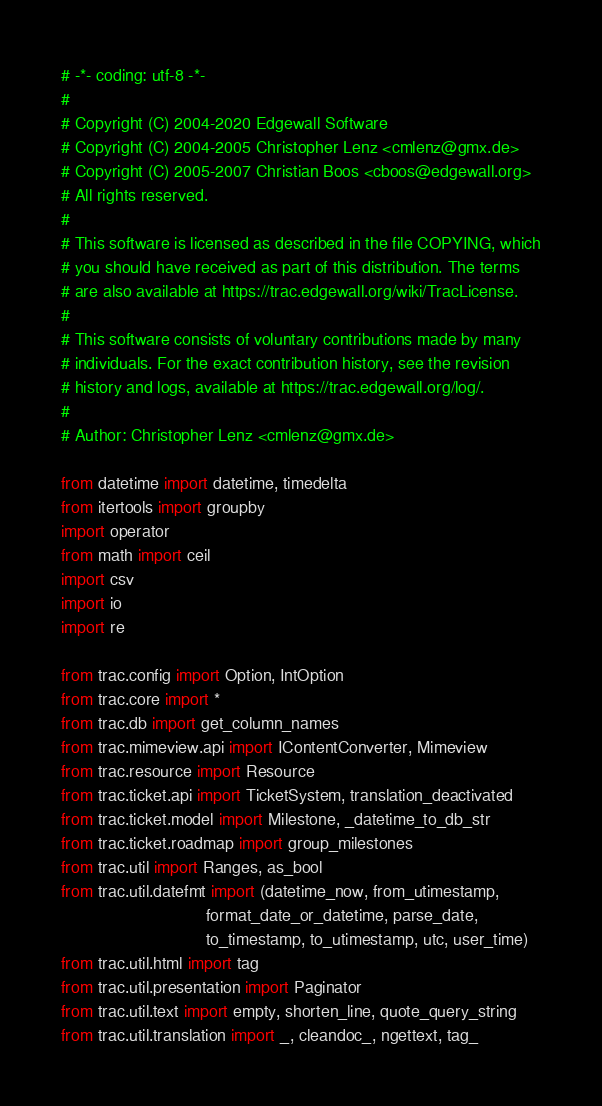<code> <loc_0><loc_0><loc_500><loc_500><_Python_># -*- coding: utf-8 -*-
#
# Copyright (C) 2004-2020 Edgewall Software
# Copyright (C) 2004-2005 Christopher Lenz <cmlenz@gmx.de>
# Copyright (C) 2005-2007 Christian Boos <cboos@edgewall.org>
# All rights reserved.
#
# This software is licensed as described in the file COPYING, which
# you should have received as part of this distribution. The terms
# are also available at https://trac.edgewall.org/wiki/TracLicense.
#
# This software consists of voluntary contributions made by many
# individuals. For the exact contribution history, see the revision
# history and logs, available at https://trac.edgewall.org/log/.
#
# Author: Christopher Lenz <cmlenz@gmx.de>

from datetime import datetime, timedelta
from itertools import groupby
import operator
from math import ceil
import csv
import io
import re

from trac.config import Option, IntOption
from trac.core import *
from trac.db import get_column_names
from trac.mimeview.api import IContentConverter, Mimeview
from trac.resource import Resource
from trac.ticket.api import TicketSystem, translation_deactivated
from trac.ticket.model import Milestone, _datetime_to_db_str
from trac.ticket.roadmap import group_milestones
from trac.util import Ranges, as_bool
from trac.util.datefmt import (datetime_now, from_utimestamp,
                               format_date_or_datetime, parse_date,
                               to_timestamp, to_utimestamp, utc, user_time)
from trac.util.html import tag
from trac.util.presentation import Paginator
from trac.util.text import empty, shorten_line, quote_query_string
from trac.util.translation import _, cleandoc_, ngettext, tag_</code> 